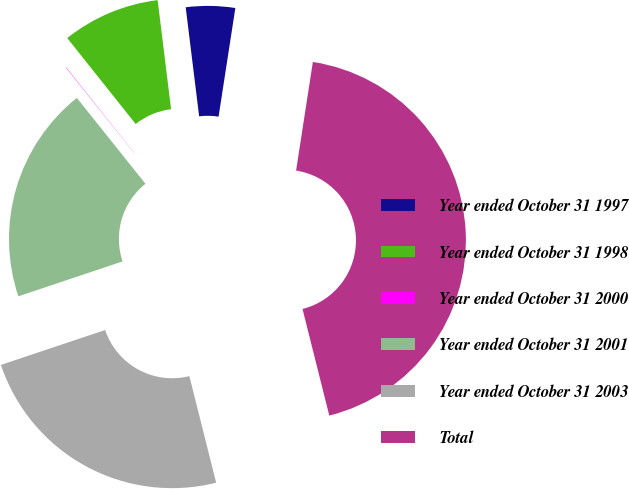Convert chart to OTSL. <chart><loc_0><loc_0><loc_500><loc_500><pie_chart><fcel>Year ended October 31 1997<fcel>Year ended October 31 1998<fcel>Year ended October 31 2000<fcel>Year ended October 31 2001<fcel>Year ended October 31 2003<fcel>Total<nl><fcel>4.39%<fcel>8.75%<fcel>0.03%<fcel>19.41%<fcel>23.77%<fcel>43.64%<nl></chart> 